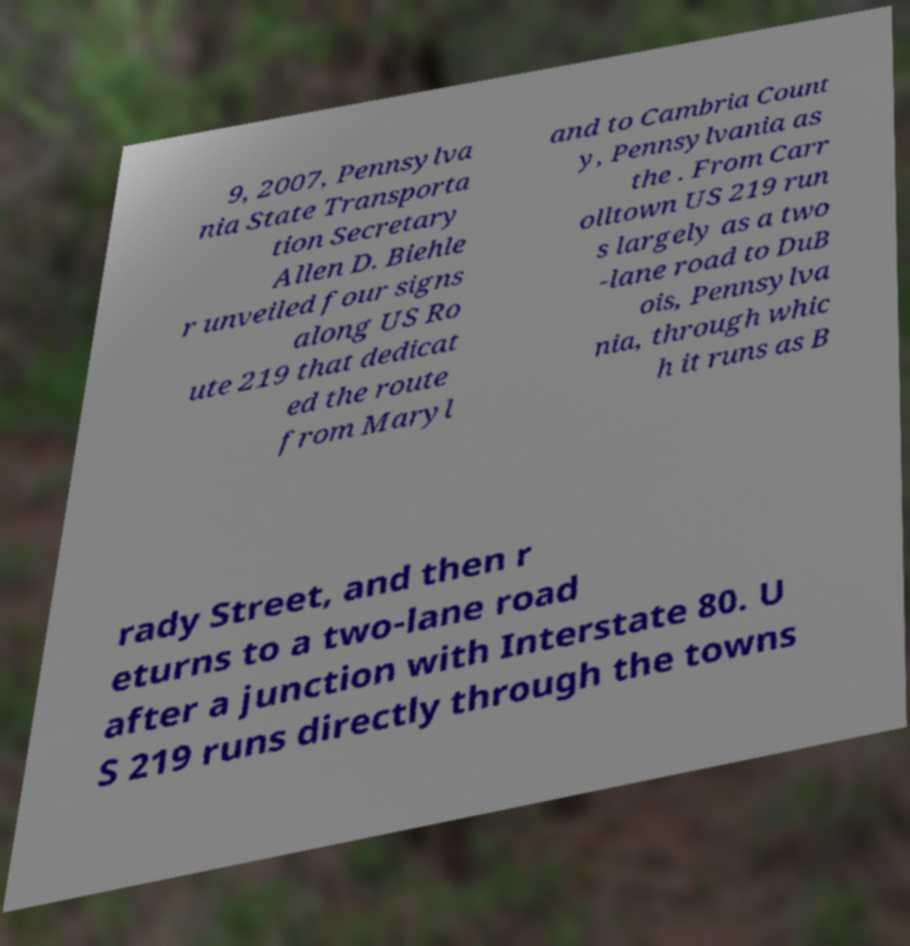For documentation purposes, I need the text within this image transcribed. Could you provide that? 9, 2007, Pennsylva nia State Transporta tion Secretary Allen D. Biehle r unveiled four signs along US Ro ute 219 that dedicat ed the route from Maryl and to Cambria Count y, Pennsylvania as the . From Carr olltown US 219 run s largely as a two -lane road to DuB ois, Pennsylva nia, through whic h it runs as B rady Street, and then r eturns to a two-lane road after a junction with Interstate 80. U S 219 runs directly through the towns 